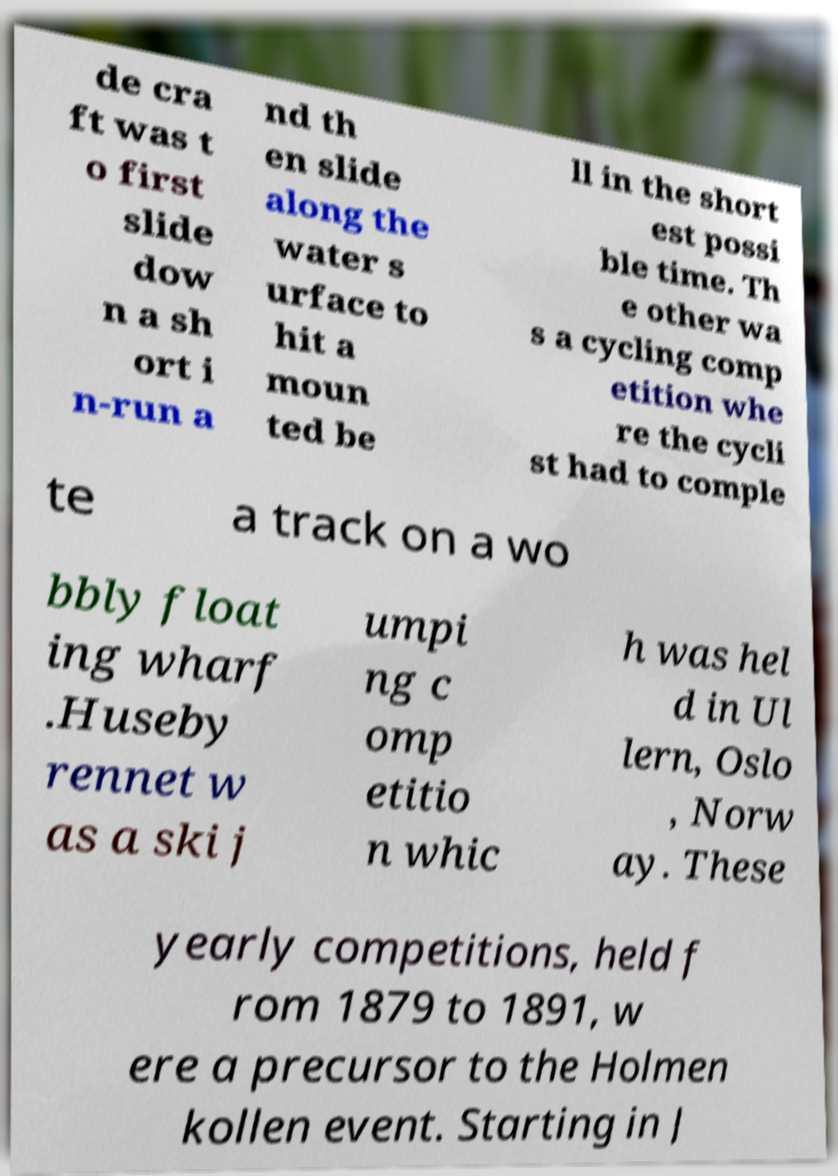Please read and relay the text visible in this image. What does it say? de cra ft was t o first slide dow n a sh ort i n-run a nd th en slide along the water s urface to hit a moun ted be ll in the short est possi ble time. Th e other wa s a cycling comp etition whe re the cycli st had to comple te a track on a wo bbly float ing wharf .Huseby rennet w as a ski j umpi ng c omp etitio n whic h was hel d in Ul lern, Oslo , Norw ay. These yearly competitions, held f rom 1879 to 1891, w ere a precursor to the Holmen kollen event. Starting in J 